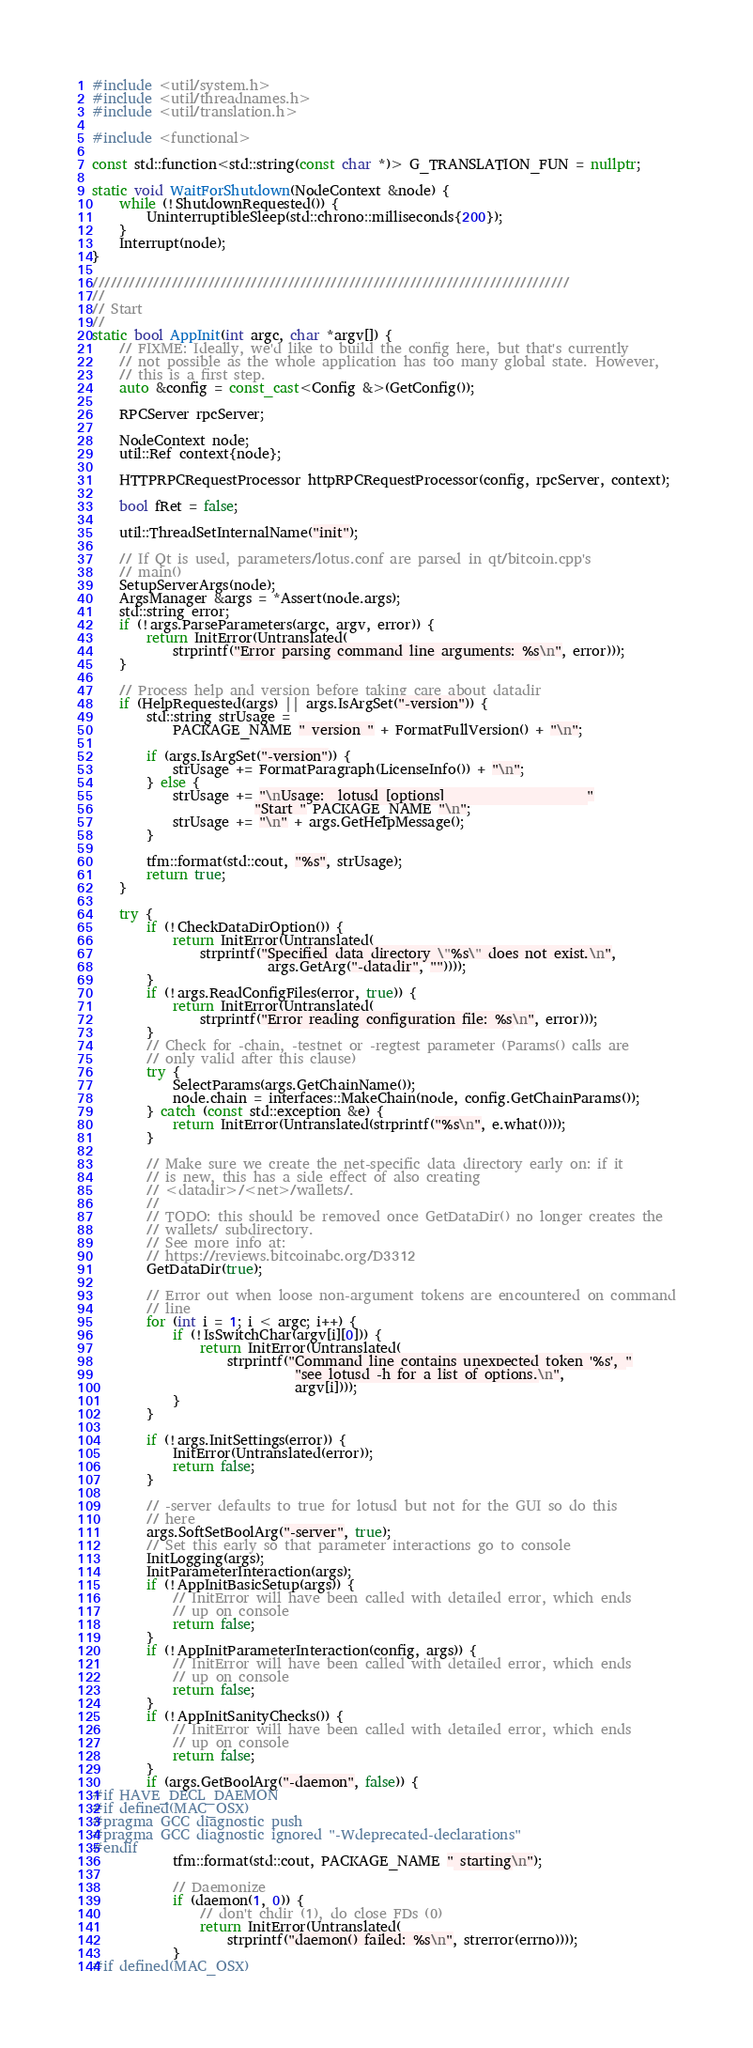Convert code to text. <code><loc_0><loc_0><loc_500><loc_500><_C++_>#include <util/system.h>
#include <util/threadnames.h>
#include <util/translation.h>

#include <functional>

const std::function<std::string(const char *)> G_TRANSLATION_FUN = nullptr;

static void WaitForShutdown(NodeContext &node) {
    while (!ShutdownRequested()) {
        UninterruptibleSleep(std::chrono::milliseconds{200});
    }
    Interrupt(node);
}

//////////////////////////////////////////////////////////////////////////////
//
// Start
//
static bool AppInit(int argc, char *argv[]) {
    // FIXME: Ideally, we'd like to build the config here, but that's currently
    // not possible as the whole application has too many global state. However,
    // this is a first step.
    auto &config = const_cast<Config &>(GetConfig());

    RPCServer rpcServer;

    NodeContext node;
    util::Ref context{node};

    HTTPRPCRequestProcessor httpRPCRequestProcessor(config, rpcServer, context);

    bool fRet = false;

    util::ThreadSetInternalName("init");

    // If Qt is used, parameters/lotus.conf are parsed in qt/bitcoin.cpp's
    // main()
    SetupServerArgs(node);
    ArgsManager &args = *Assert(node.args);
    std::string error;
    if (!args.ParseParameters(argc, argv, error)) {
        return InitError(Untranslated(
            strprintf("Error parsing command line arguments: %s\n", error)));
    }

    // Process help and version before taking care about datadir
    if (HelpRequested(args) || args.IsArgSet("-version")) {
        std::string strUsage =
            PACKAGE_NAME " version " + FormatFullVersion() + "\n";

        if (args.IsArgSet("-version")) {
            strUsage += FormatParagraph(LicenseInfo()) + "\n";
        } else {
            strUsage += "\nUsage:  lotusd [options]                     "
                        "Start " PACKAGE_NAME "\n";
            strUsage += "\n" + args.GetHelpMessage();
        }

        tfm::format(std::cout, "%s", strUsage);
        return true;
    }

    try {
        if (!CheckDataDirOption()) {
            return InitError(Untranslated(
                strprintf("Specified data directory \"%s\" does not exist.\n",
                          args.GetArg("-datadir", ""))));
        }
        if (!args.ReadConfigFiles(error, true)) {
            return InitError(Untranslated(
                strprintf("Error reading configuration file: %s\n", error)));
        }
        // Check for -chain, -testnet or -regtest parameter (Params() calls are
        // only valid after this clause)
        try {
            SelectParams(args.GetChainName());
            node.chain = interfaces::MakeChain(node, config.GetChainParams());
        } catch (const std::exception &e) {
            return InitError(Untranslated(strprintf("%s\n", e.what())));
        }

        // Make sure we create the net-specific data directory early on: if it
        // is new, this has a side effect of also creating
        // <datadir>/<net>/wallets/.
        //
        // TODO: this should be removed once GetDataDir() no longer creates the
        // wallets/ subdirectory.
        // See more info at:
        // https://reviews.bitcoinabc.org/D3312
        GetDataDir(true);

        // Error out when loose non-argument tokens are encountered on command
        // line
        for (int i = 1; i < argc; i++) {
            if (!IsSwitchChar(argv[i][0])) {
                return InitError(Untranslated(
                    strprintf("Command line contains unexpected token '%s', "
                              "see lotusd -h for a list of options.\n",
                              argv[i])));
            }
        }

        if (!args.InitSettings(error)) {
            InitError(Untranslated(error));
            return false;
        }

        // -server defaults to true for lotusd but not for the GUI so do this
        // here
        args.SoftSetBoolArg("-server", true);
        // Set this early so that parameter interactions go to console
        InitLogging(args);
        InitParameterInteraction(args);
        if (!AppInitBasicSetup(args)) {
            // InitError will have been called with detailed error, which ends
            // up on console
            return false;
        }
        if (!AppInitParameterInteraction(config, args)) {
            // InitError will have been called with detailed error, which ends
            // up on console
            return false;
        }
        if (!AppInitSanityChecks()) {
            // InitError will have been called with detailed error, which ends
            // up on console
            return false;
        }
        if (args.GetBoolArg("-daemon", false)) {
#if HAVE_DECL_DAEMON
#if defined(MAC_OSX)
#pragma GCC diagnostic push
#pragma GCC diagnostic ignored "-Wdeprecated-declarations"
#endif
            tfm::format(std::cout, PACKAGE_NAME " starting\n");

            // Daemonize
            if (daemon(1, 0)) {
                // don't chdir (1), do close FDs (0)
                return InitError(Untranslated(
                    strprintf("daemon() failed: %s\n", strerror(errno))));
            }
#if defined(MAC_OSX)</code> 